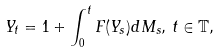<formula> <loc_0><loc_0><loc_500><loc_500>Y _ { t } = 1 + \int _ { 0 } ^ { t } F ( Y _ { s } ) d M _ { s } , \, t \in \mathbb { T } ,</formula> 